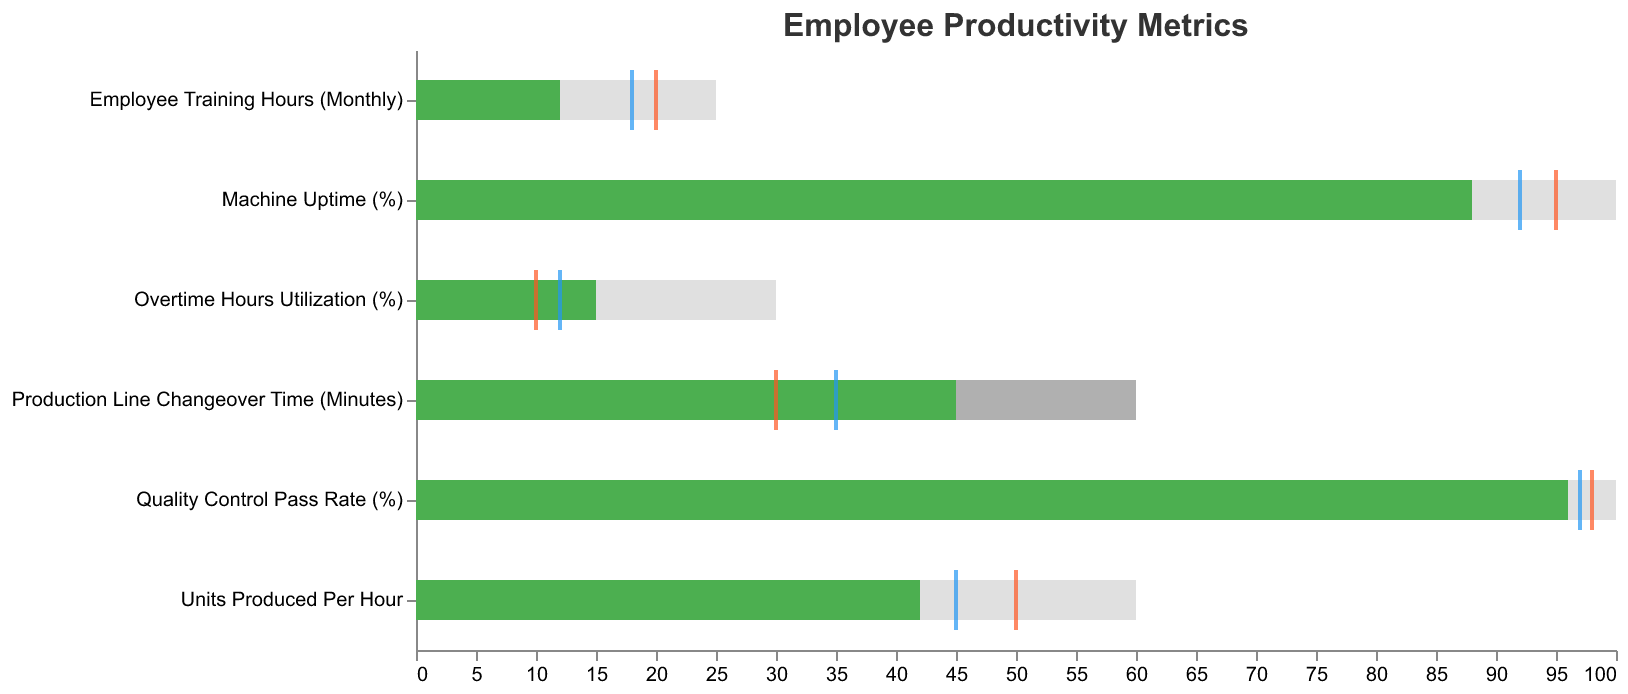*What is the title of the figure?* The figure title is prominently displayed at the top, indicating the main subject of the chart.
Answer: Employee Productivity Metrics *How many metrics are displayed in the chart?* By looking at the y-axis, we can count the number of unique entries listed under the "Metric" category.
Answer: 6 *What is the actual value for 'Units Produced Per Hour'?* The actual value is represented by the green bar within the corresponding 'Units Produced Per Hour' metric.
Answer: 42 *How does the actual value for 'Machine Uptime (%)' compare to the target?* The actual value (88) can be compared to the target value (marked by a red tick) of 95 by looking at their positions.
Answer: Less than the target *Which metric has the highest target value?* By scanning the red ticks along the x-axis, we can identify the highest value.
Answer: Machine Uptime (%) *What is the range defined as 'Good' for 'Employee Training Hours (Monthly)'?* The 'Good' range is highlighted by the lightest gray bar, spanning from its end value to the edge of the figure.
Answer: 10-25 *Does 'Overtime Hours Utilization (%)' exceed the industry average?* The blue tick representing the industry average value is compared to the green bar representing the actual value.
Answer: Yes *Which metric falls under the satisfactory category based on the actual value?* The green bar (actual value) falling within or equal to the medium gray 'Satisfactory' range is considered satisfactory.
Answer: Overtime Hours Utilization (%) *How much more is the industry average for 'Quality Control Pass Rate (%)' compared to the actual value?* Subtract the actual value (96) from the industry average (97).
Answer: 1% *For 'Production Line Changeover Time (Minutes)', is the actual value within the satisfactory range?* The actual value (45) is checked against the medium gray bar range indicating satisfactory (0 to 60).
Answer: Yes 